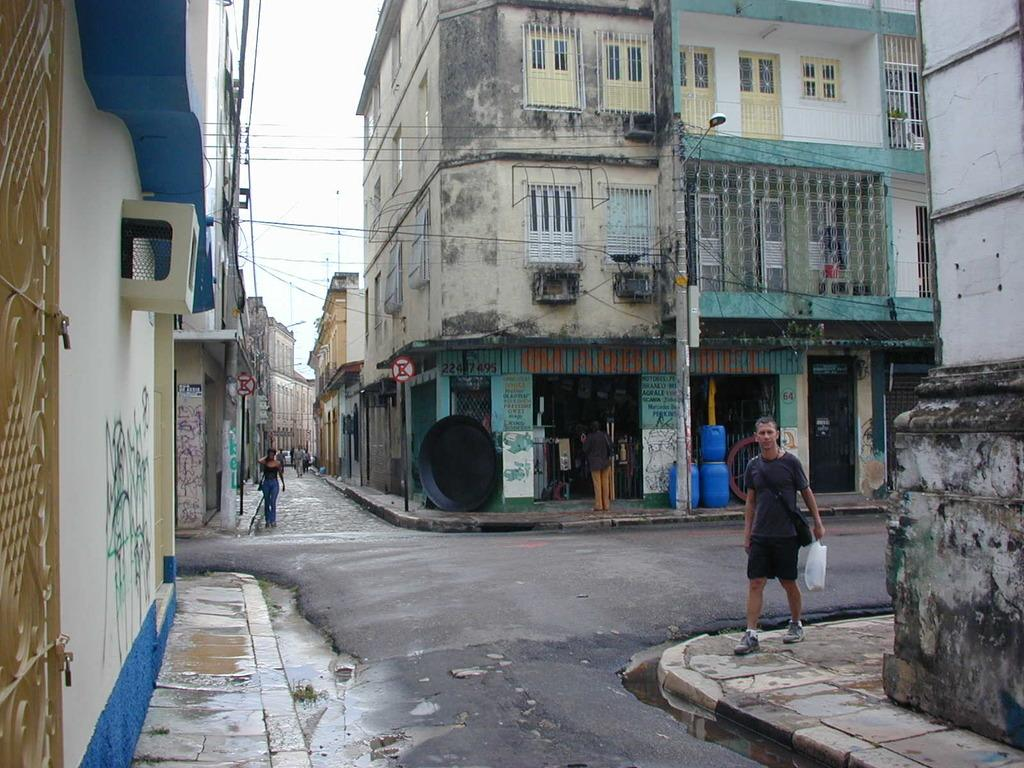What are the people in the image doing? The people in the image are walking on the ground. What can be seen in the background of the image? In the background of the image, there are wires, street lights, buildings, the sky, blue color objects, and other objects. Can you describe the color of the objects in the background? The objects in the background have a blue color. What else is present in the background of the image? There are other objects in the background of the image, but their specific details are not mentioned in the provided facts. Is there a camera visible in the image? There is no mention of a camera in the provided facts, so it cannot be determined if one is present in the image. 